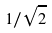<formula> <loc_0><loc_0><loc_500><loc_500>1 / \sqrt { 2 }</formula> 